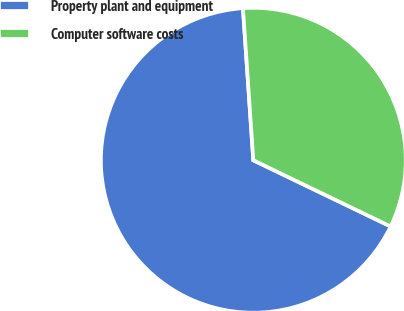<chart> <loc_0><loc_0><loc_500><loc_500><pie_chart><fcel>Property plant and equipment<fcel>Computer software costs<nl><fcel>66.77%<fcel>33.23%<nl></chart> 